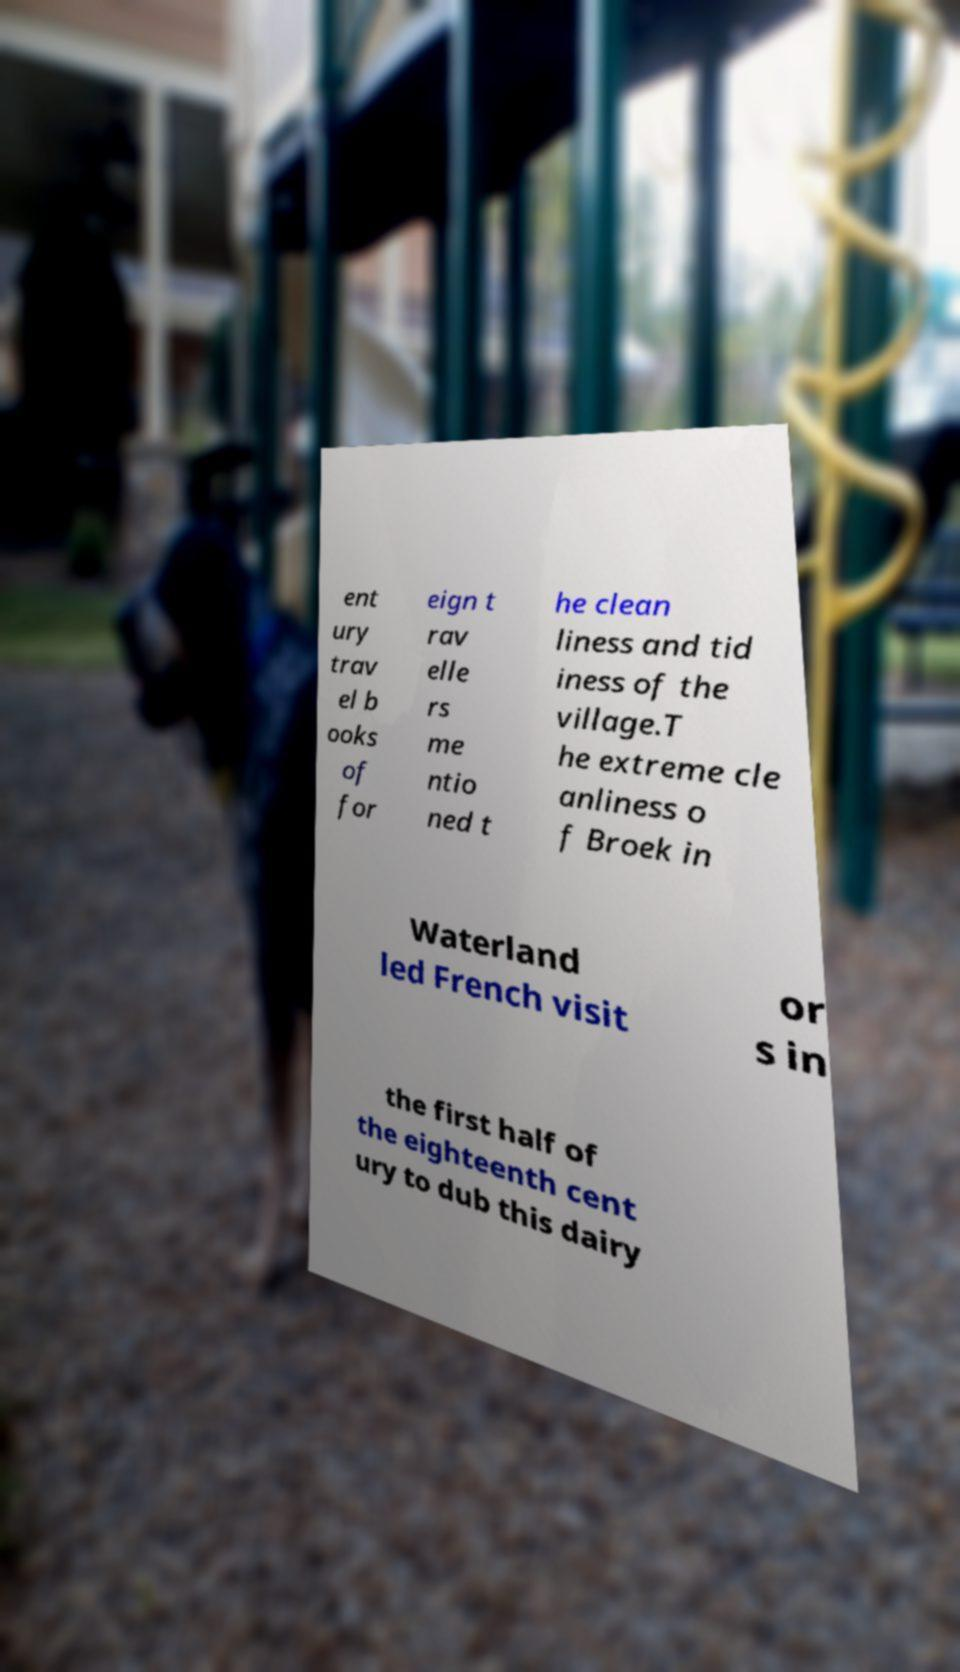What messages or text are displayed in this image? I need them in a readable, typed format. ent ury trav el b ooks of for eign t rav elle rs me ntio ned t he clean liness and tid iness of the village.T he extreme cle anliness o f Broek in Waterland led French visit or s in the first half of the eighteenth cent ury to dub this dairy 